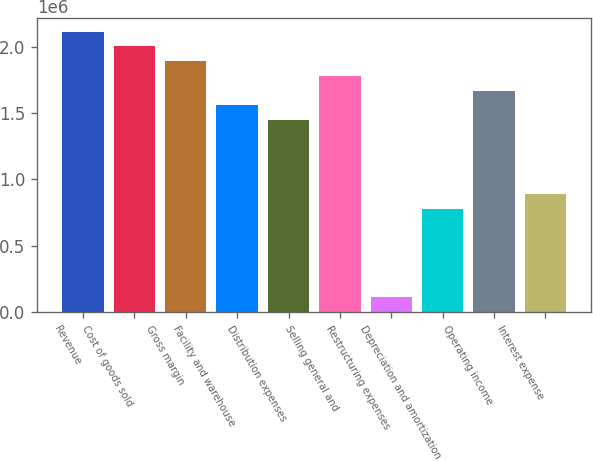<chart> <loc_0><loc_0><loc_500><loc_500><bar_chart><fcel>Revenue<fcel>Cost of goods sold<fcel>Gross margin<fcel>Facility and warehouse<fcel>Distribution expenses<fcel>Selling general and<fcel>Restructuring expenses<fcel>Depreciation and amortization<fcel>Operating income<fcel>Interest expense<nl><fcel>2.11347e+06<fcel>2.00223e+06<fcel>1.891e+06<fcel>1.55729e+06<fcel>1.44606e+06<fcel>1.77976e+06<fcel>111236<fcel>778646<fcel>1.66853e+06<fcel>889881<nl></chart> 